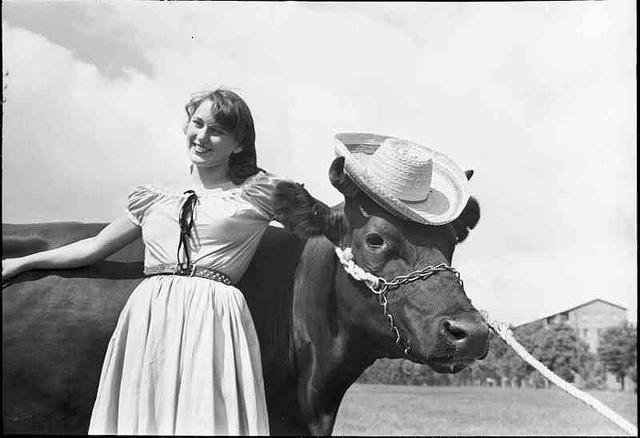Does the description: "The person is facing away from the cow." accurately reflect the image?
Answer yes or no. Yes. 